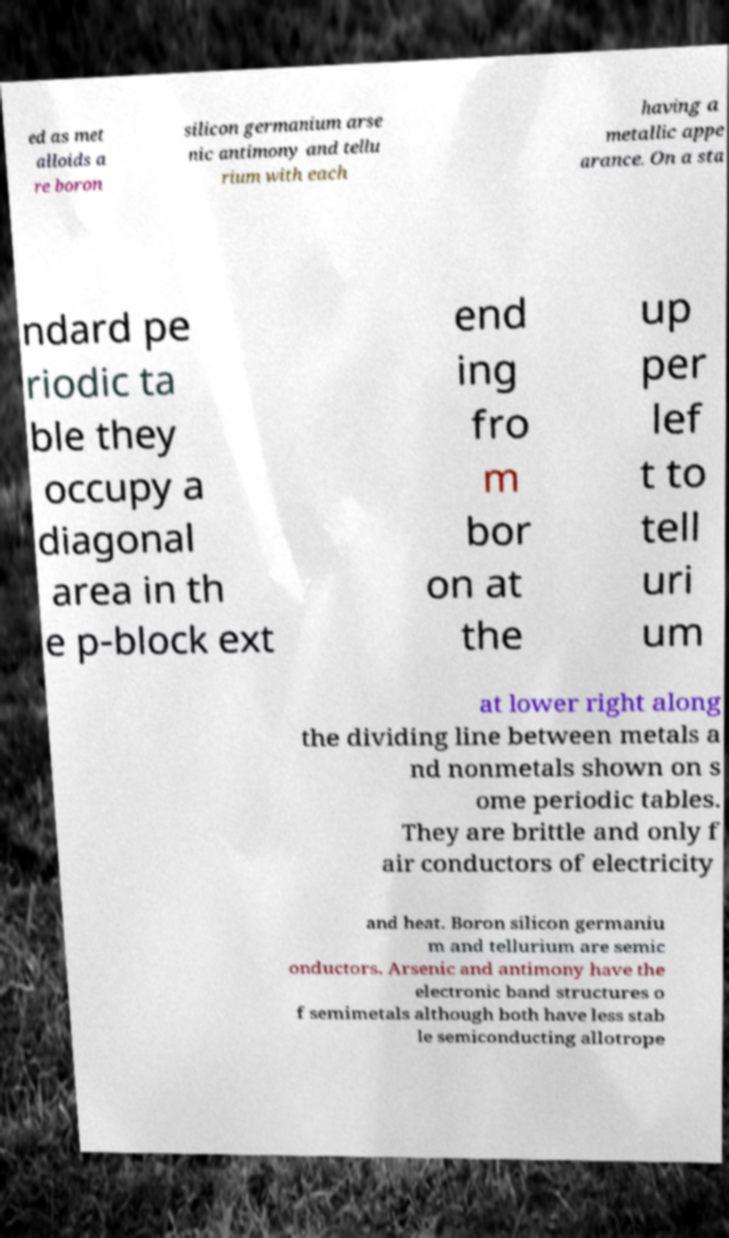Could you assist in decoding the text presented in this image and type it out clearly? ed as met alloids a re boron silicon germanium arse nic antimony and tellu rium with each having a metallic appe arance. On a sta ndard pe riodic ta ble they occupy a diagonal area in th e p-block ext end ing fro m bor on at the up per lef t to tell uri um at lower right along the dividing line between metals a nd nonmetals shown on s ome periodic tables. They are brittle and only f air conductors of electricity and heat. Boron silicon germaniu m and tellurium are semic onductors. Arsenic and antimony have the electronic band structures o f semimetals although both have less stab le semiconducting allotrope 